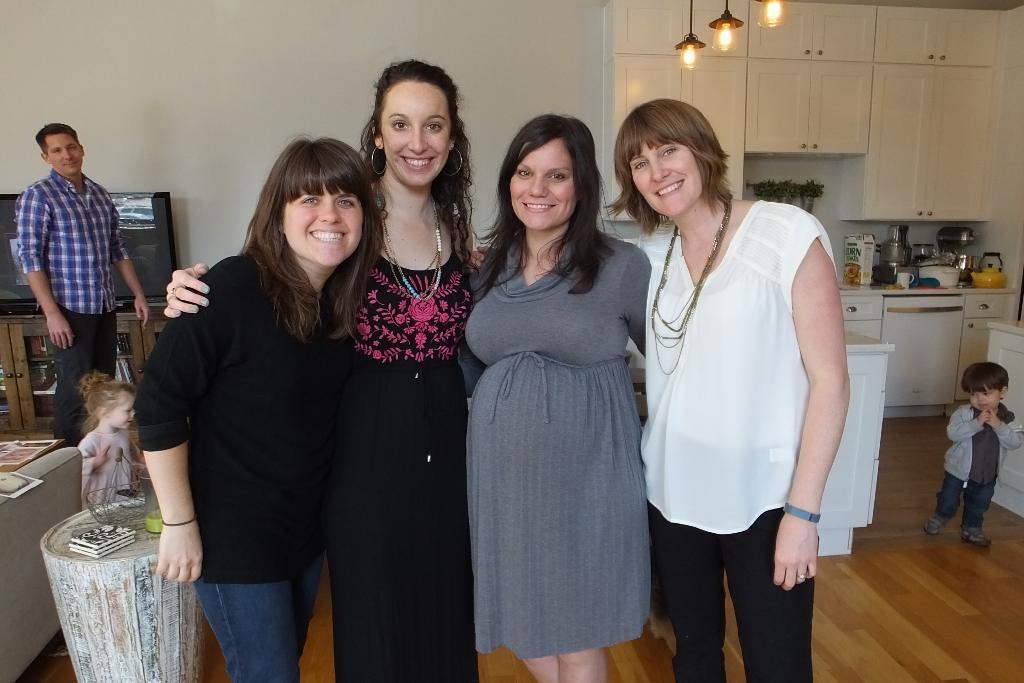How would you summarize this image in a sentence or two? In the picture we can see group of women standing together and posing for a photograph and in the background of the picture there is a man and two kids standing, there is a television, some cupboards, we can see some utensils which are on the surface and there is a wall. 